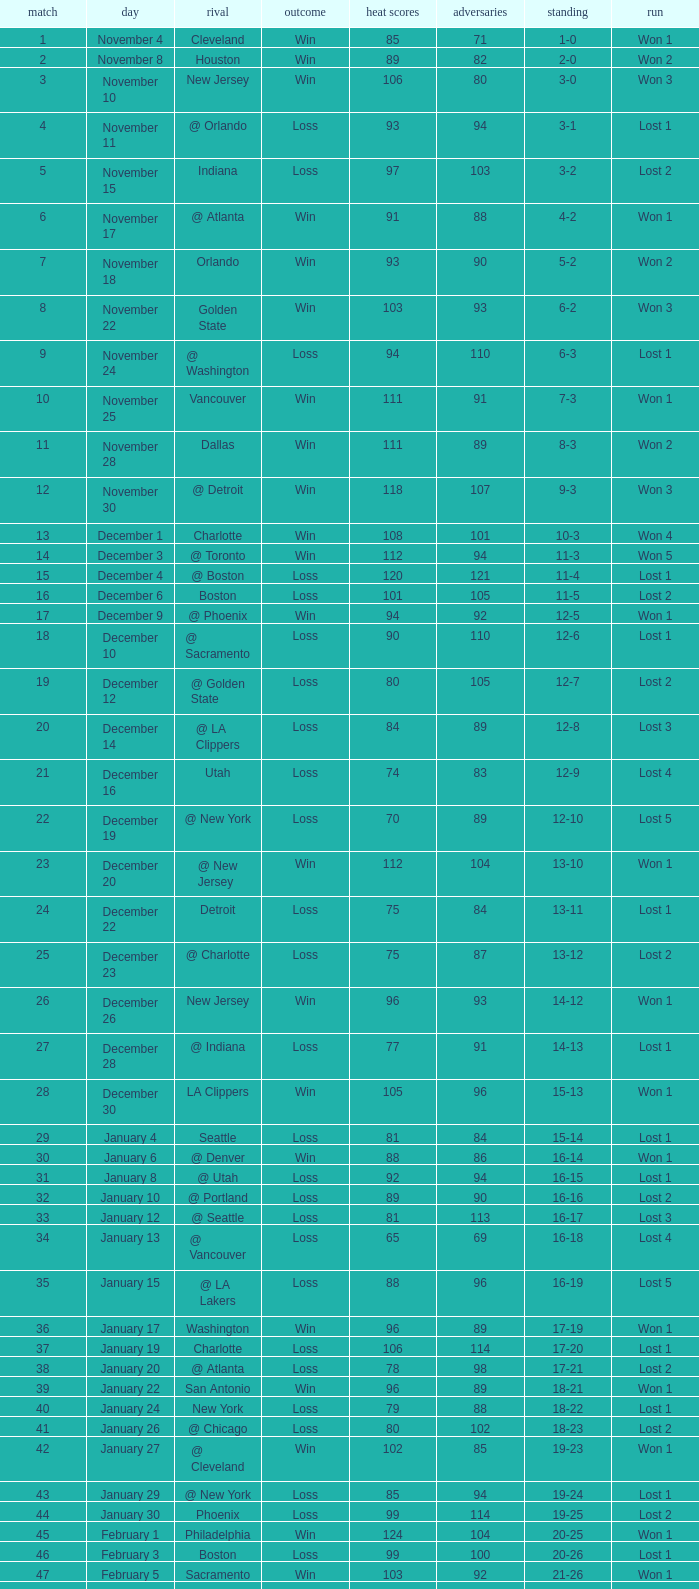What is Heat Points, when Game is less than 80, and when Date is "April 26 (First Round)"? 85.0. 